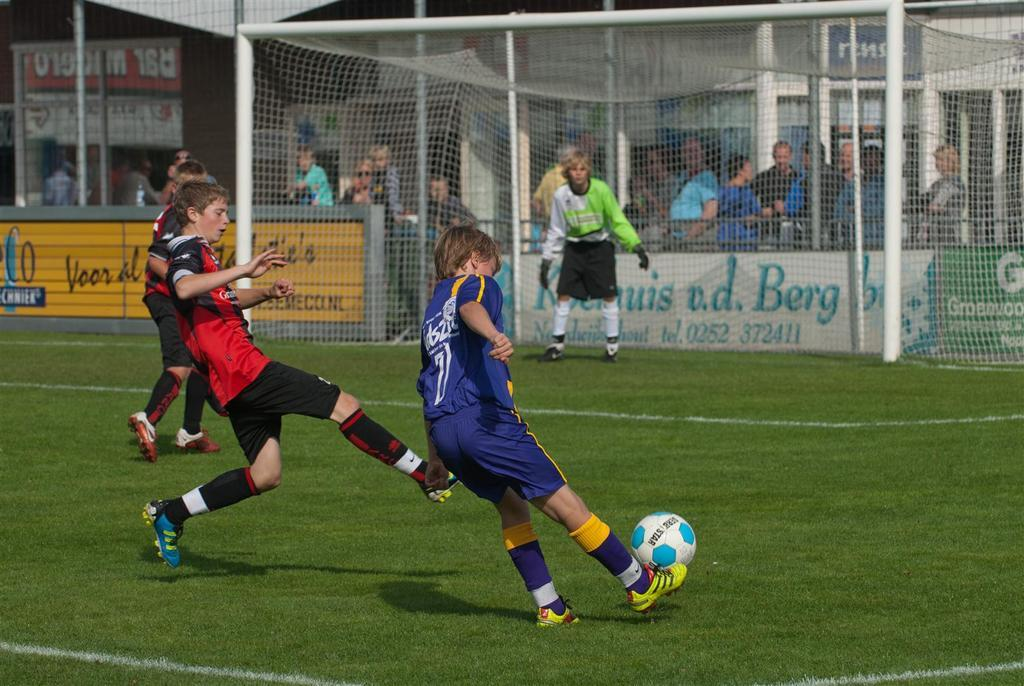<image>
Offer a succinct explanation of the picture presented. Player number 7 kicks the ball in a boy's soccer game. 